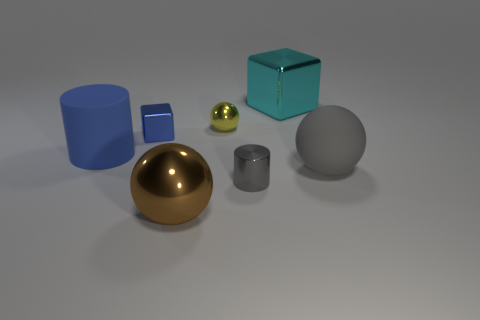There is a matte thing on the right side of the shiny object that is to the right of the small shiny cylinder; what shape is it?
Make the answer very short. Sphere. Is the number of brown spheres that are behind the big brown thing less than the number of spheres in front of the tiny cube?
Your response must be concise. Yes. The rubber object that is the same shape as the small gray metal object is what size?
Your answer should be very brief. Large. How many things are either big spheres right of the large brown metal object or tiny shiny objects that are in front of the large gray sphere?
Offer a terse response. 2. Do the yellow sphere and the blue cylinder have the same size?
Make the answer very short. No. Is the number of big green shiny cylinders greater than the number of tiny blue metallic things?
Ensure brevity in your answer.  No. How many other objects are the same color as the metallic cylinder?
Give a very brief answer. 1. What number of things are brown objects or small gray objects?
Your answer should be very brief. 2. Do the large rubber thing that is in front of the big rubber cylinder and the big cyan metal object have the same shape?
Offer a very short reply. No. What is the color of the big block behind the gray metallic thing that is in front of the yellow sphere?
Keep it short and to the point. Cyan. 